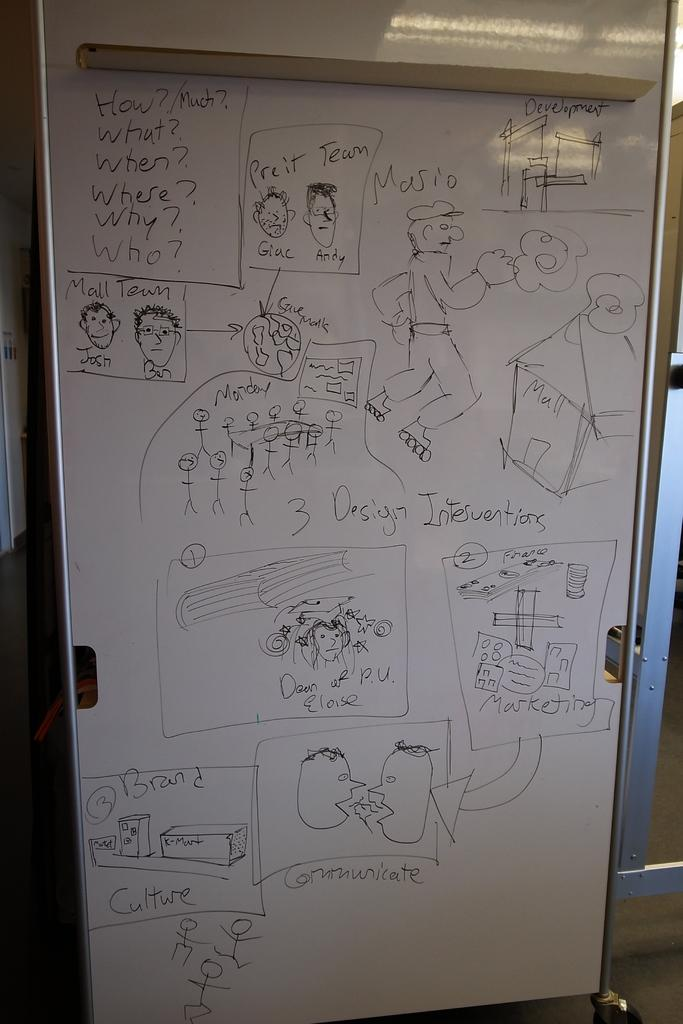What is the main object in the middle of the image? There is a board in the middle of the image. What is depicted on the board? There is a drawing on the board. What rhythm is the board following in the image? The board does not follow a rhythm in the image; it is a static object with a drawing on it. How does the elbow interact with the board in the image? There is no elbow present in the image, so it cannot interact with the board. 